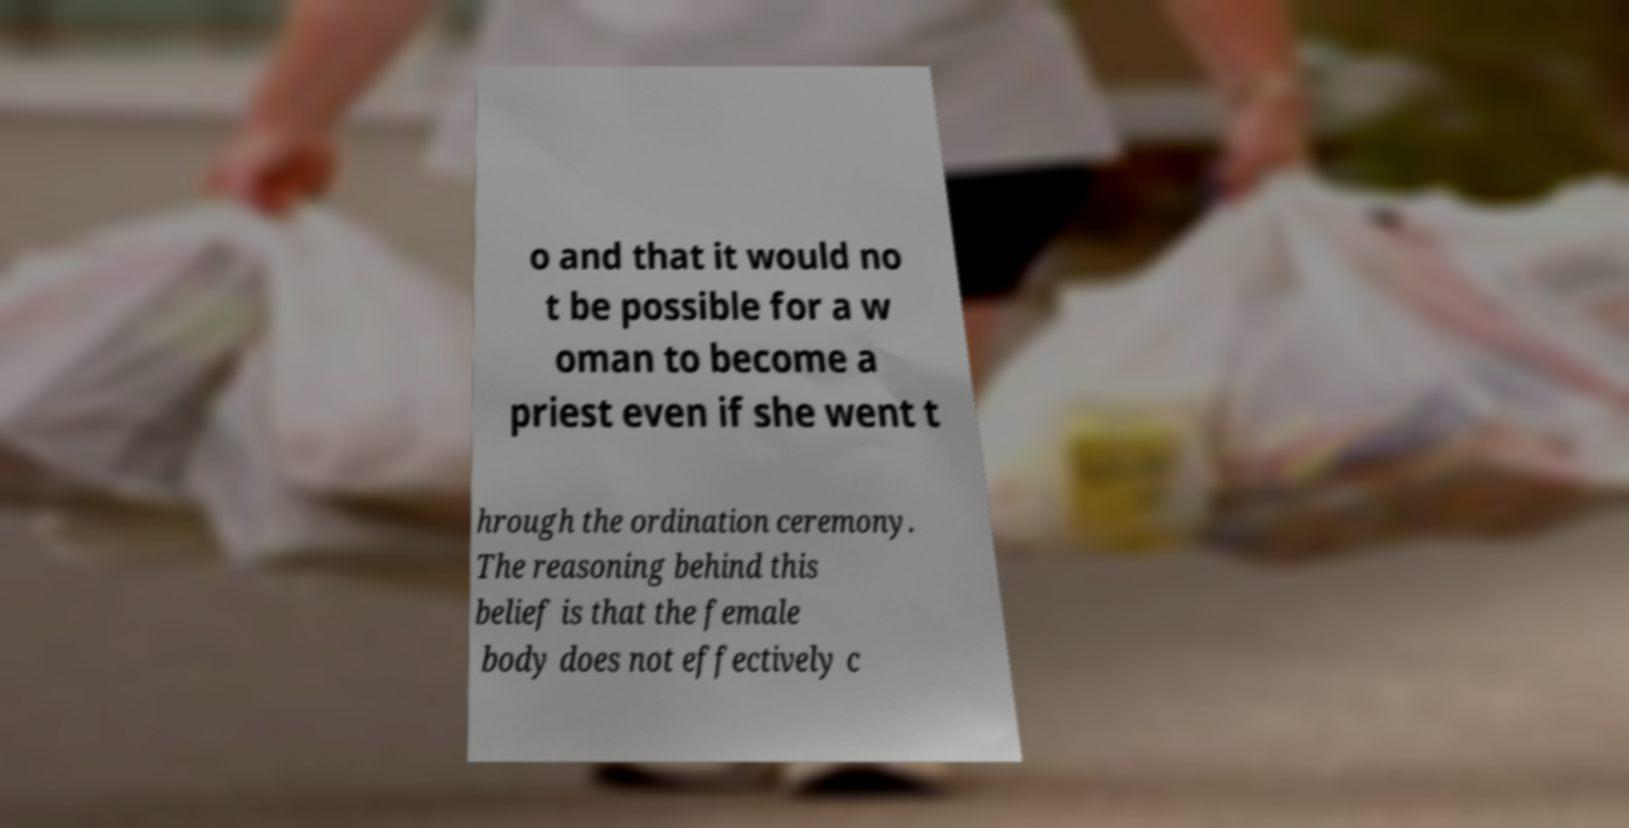There's text embedded in this image that I need extracted. Can you transcribe it verbatim? o and that it would no t be possible for a w oman to become a priest even if she went t hrough the ordination ceremony. The reasoning behind this belief is that the female body does not effectively c 